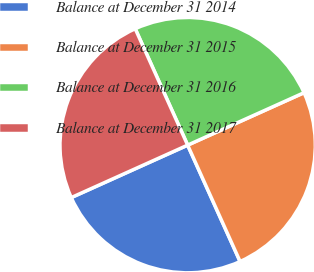<chart> <loc_0><loc_0><loc_500><loc_500><pie_chart><fcel>Balance at December 31 2014<fcel>Balance at December 31 2015<fcel>Balance at December 31 2016<fcel>Balance at December 31 2017<nl><fcel>25.0%<fcel>25.0%<fcel>25.0%<fcel>25.0%<nl></chart> 